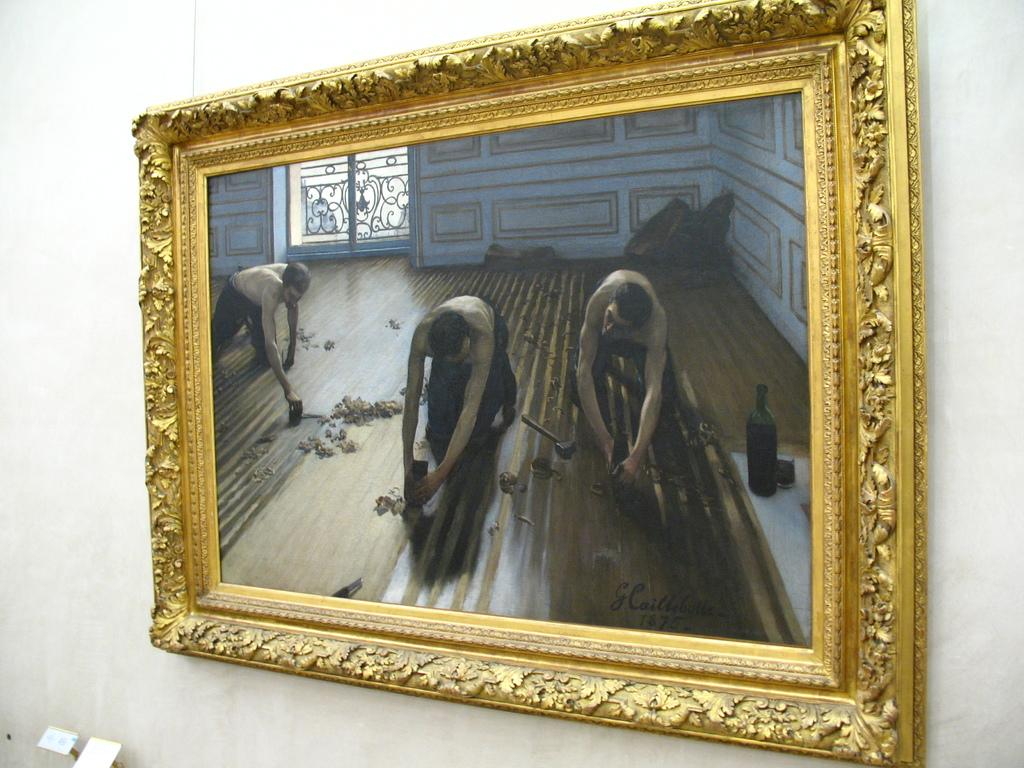What can be seen in the image? There is a photo frame in the image, and within the photo, there are objects on the wall, a wall visible, a window visible, three persons working on the floor, and a wine bottle on a table. What is the main subject of the photo within the image? The main subject of the photo within the image is three persons working on the floor. What can be seen on the wall in the photo? In the photo, there are objects on the wall visible. What is the setting of the photo within the image? The setting of the photo within the image includes a wall, a window, and a table with a wine bottle. What type of bridge can be seen in the image? There is no bridge present in the image. What kind of quartz is visible on the table in the image? There is no quartz present in the image. 